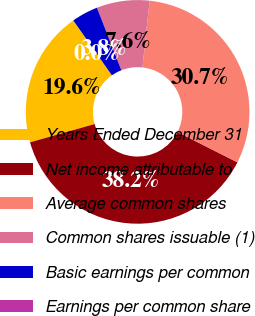Convert chart to OTSL. <chart><loc_0><loc_0><loc_500><loc_500><pie_chart><fcel>Years Ended December 31<fcel>Net income attributable to<fcel>Average common shares<fcel>Common shares issuable (1)<fcel>Basic earnings per common<fcel>Earnings per common share<nl><fcel>19.62%<fcel>38.16%<fcel>30.74%<fcel>7.64%<fcel>3.83%<fcel>0.01%<nl></chart> 